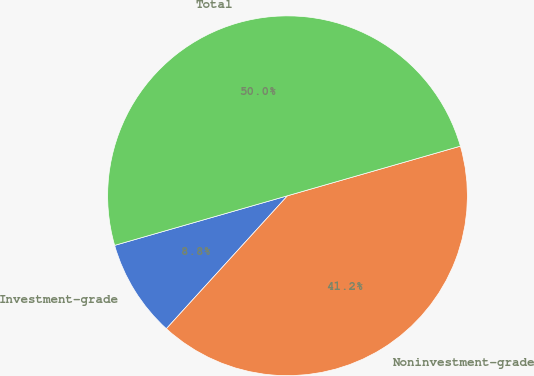<chart> <loc_0><loc_0><loc_500><loc_500><pie_chart><fcel>Investment-grade<fcel>Noninvestment-grade<fcel>Total<nl><fcel>8.79%<fcel>41.21%<fcel>50.0%<nl></chart> 